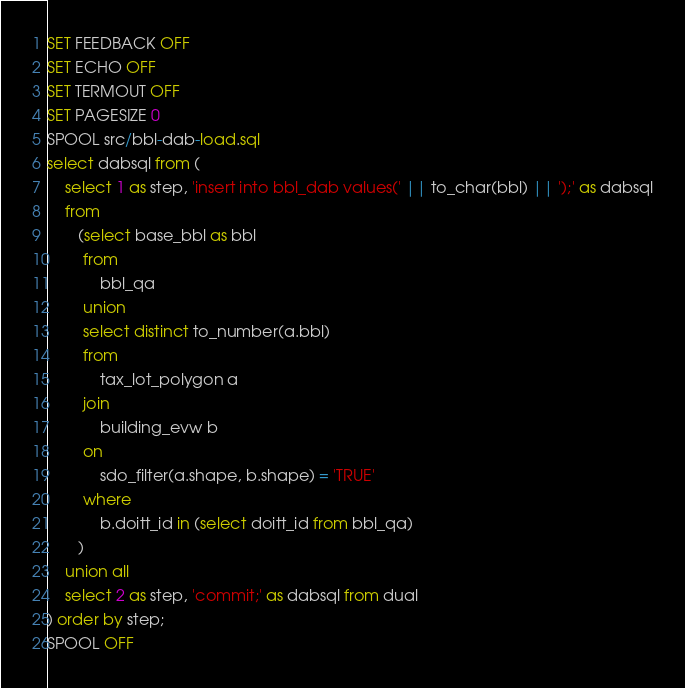<code> <loc_0><loc_0><loc_500><loc_500><_SQL_>SET FEEDBACK OFF
SET ECHO OFF
SET TERMOUT OFF
SET PAGESIZE 0
SPOOL src/bbl-dab-load.sql
select dabsql from (
    select 1 as step, 'insert into bbl_dab values(' || to_char(bbl) || ');' as dabsql
    from 
       (select base_bbl as bbl 
        from 
            bbl_qa
        union
        select distinct to_number(a.bbl) 
        from 
            tax_lot_polygon a
        join
            building_evw b
        on 
            sdo_filter(a.shape, b.shape) = 'TRUE'
        where 
            b.doitt_id in (select doitt_id from bbl_qa)
       )
    union all
    select 2 as step, 'commit;' as dabsql from dual
) order by step;
SPOOL OFF</code> 